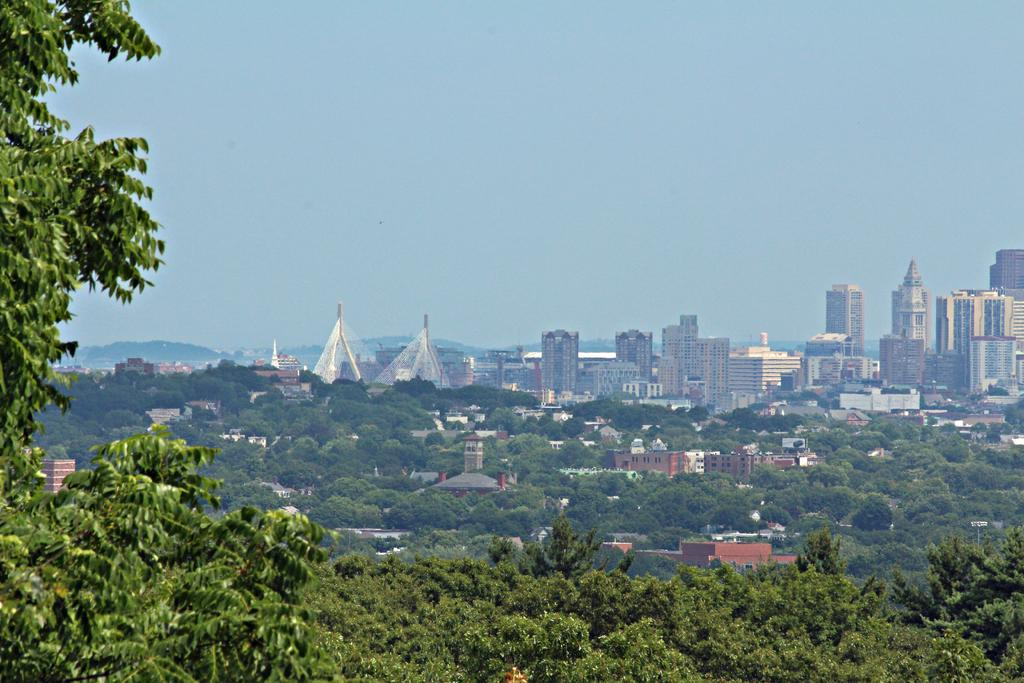What type of natural elements can be seen in the image? There are trees in the image. What type of man-made structures are present in the image? There are buildings in the image. What can be seen in the distance in the image? Hills are visible in the background of the image. What is visible above the trees and buildings in the image? The sky is visible in the background of the image. What type of pie is being served at the picnic in the image? There is no picnic or pie present in the image. What type of animal can be seen grazing in the field in the image? There is no animal grazing in the field in the image; it only features trees, buildings, hills, and the sky. 